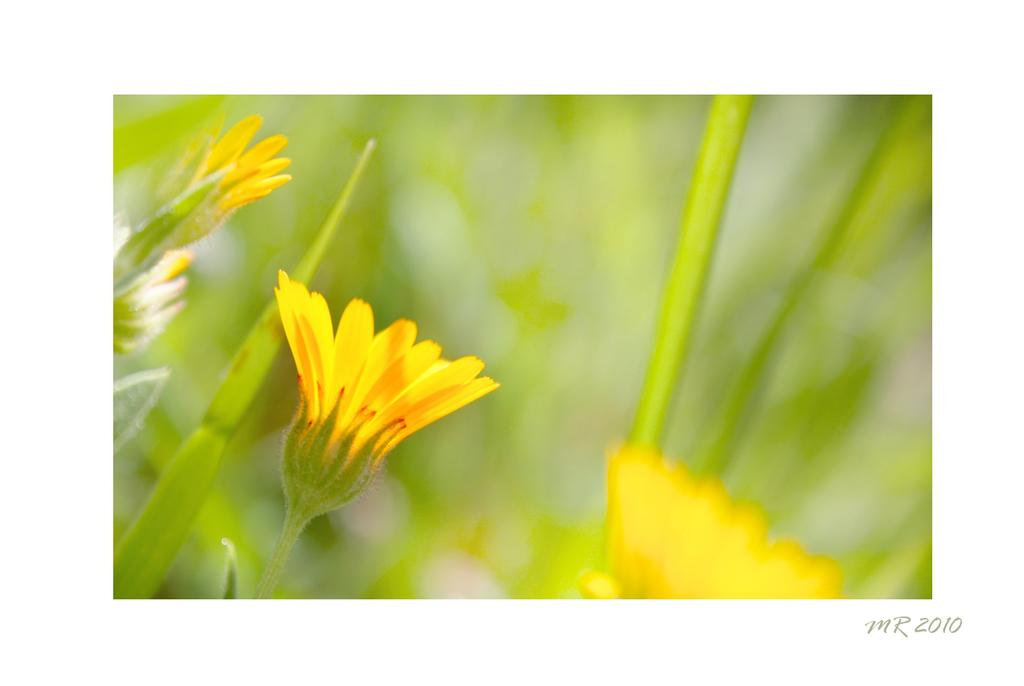What is present in the image that features a design or message? There is a poster in the image. What is the main visual element on the poster? The poster contains yellow color flowers. Are the flowers on the poster part of a larger object or organism? Yes, the flowers are associated with plants. What type of bells can be heard ringing in the image? There are no bells present in the image, and therefore no sound can be heard. 